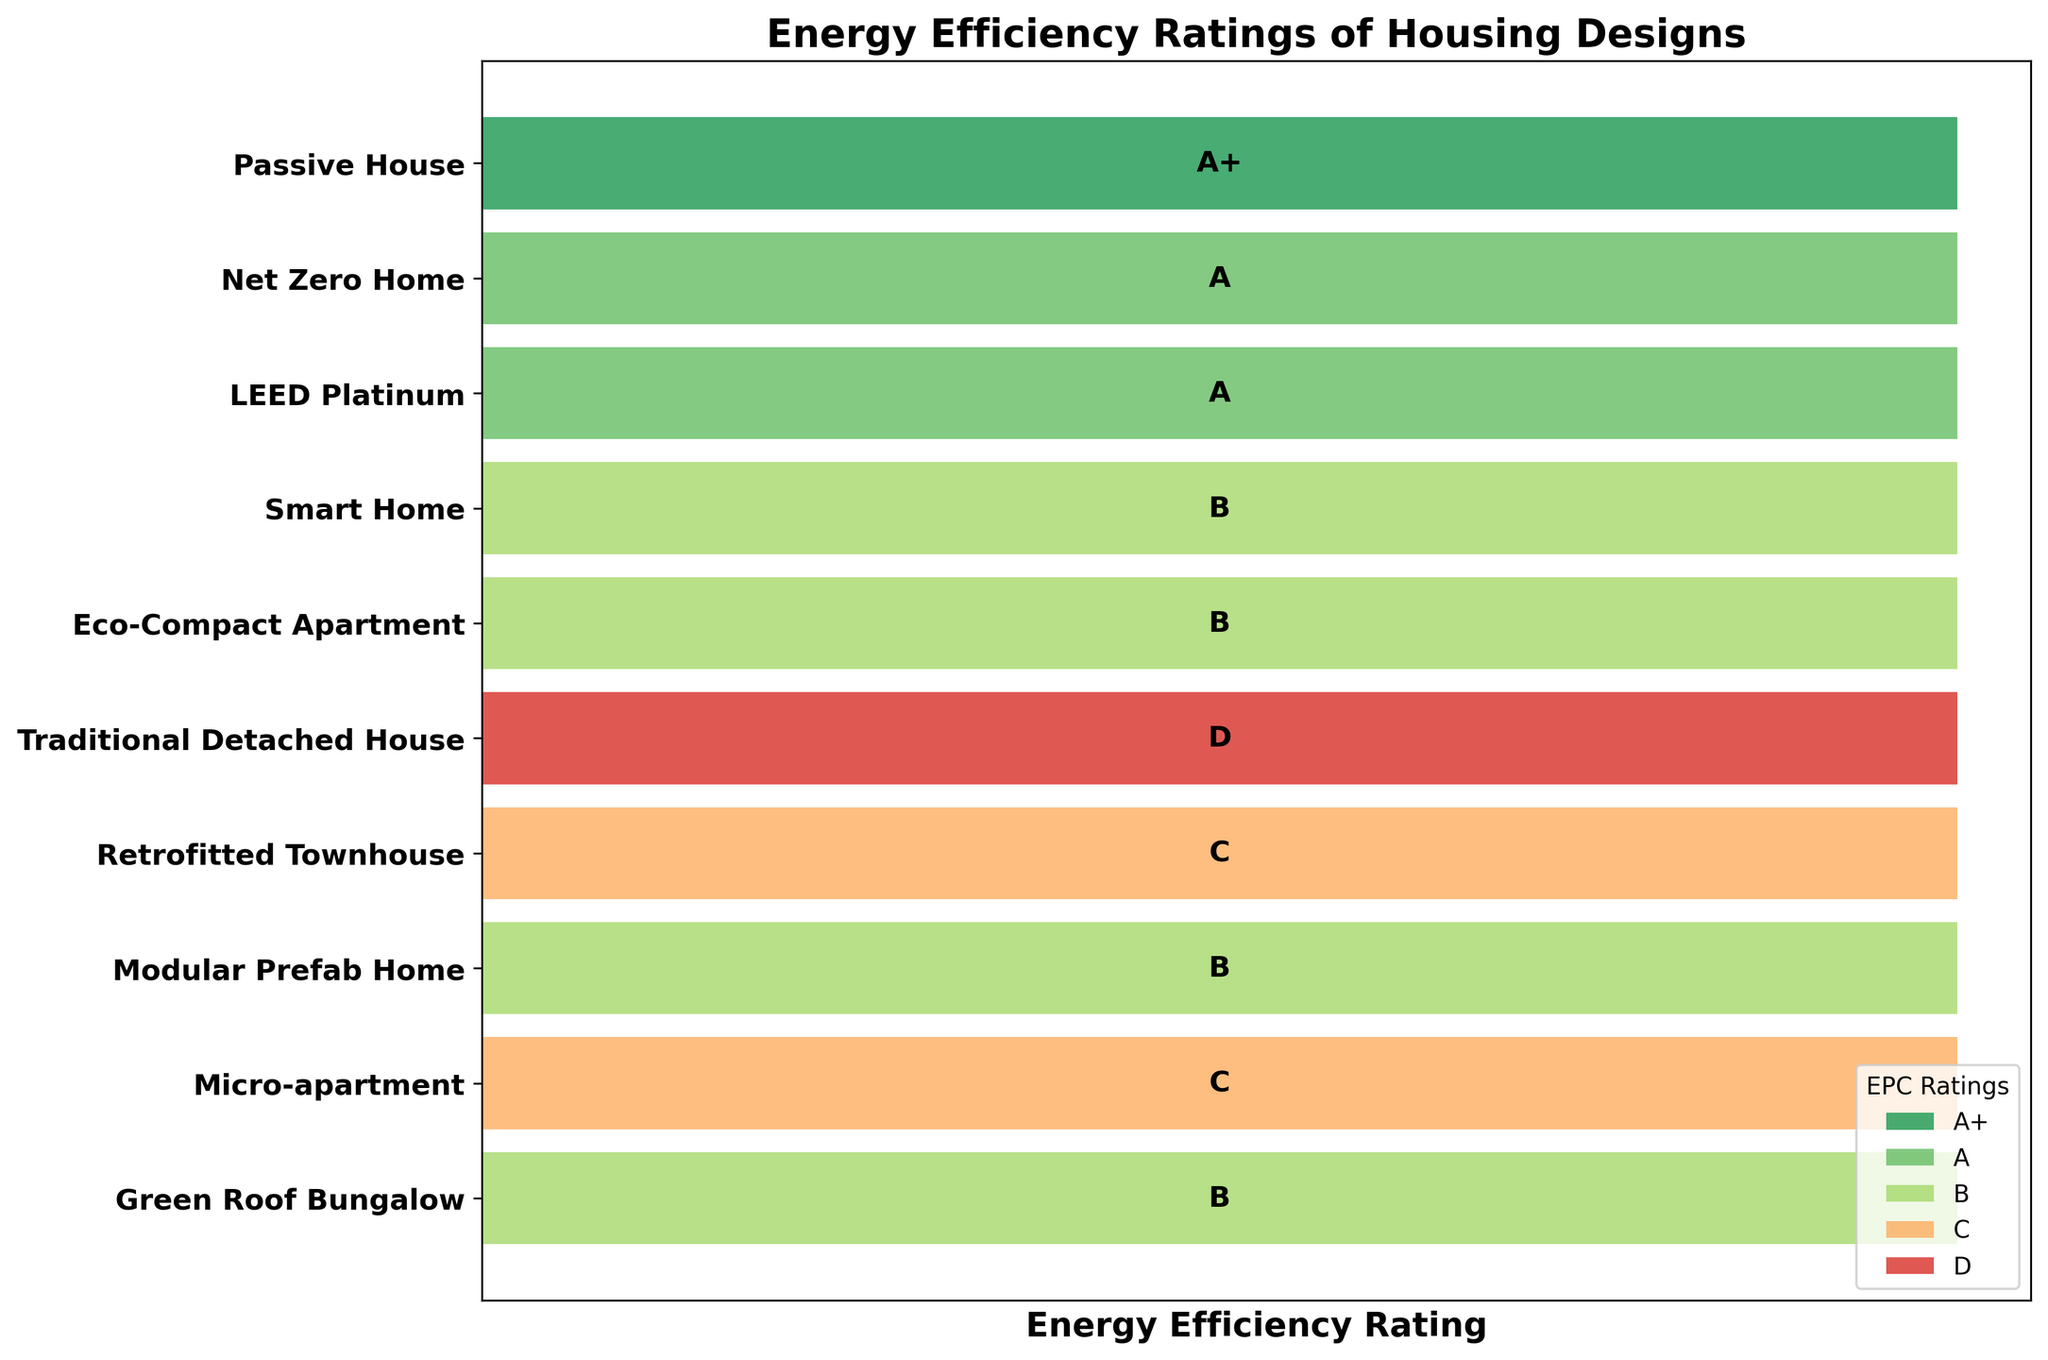How many unique housing designs are displayed in the figure? Count the number of different labels on the y-axis representing the designs.
Answer: 10 What is the title of the figure? The title is usually placed at the top of the graph.
Answer: Energy Efficiency Ratings of Housing Designs Which housing design has the highest energy efficiency rating? Identify the design label next to the bar with the highest rating of 'A+'.
Answer: Passive House How many housing designs have an energy efficiency rating of B? Count the bars shaded with the same color corresponding to the rating 'B'.
Answer: 5 What is the average energy efficiency rating for the displayed housing designs? Identify the ratings for all designs, assign numerical values (A+ = 1, A = 2, B = 3, C = 4, D = 5), sum them up, and divide by the number of designs.
Answer: 2.9 Which housing designs have a rating lower than a B? Identify the labels next to the bars rated as 'C' or 'D'.
Answer: Retrofitted Townhouse, Micro-apartment, Traditional Detached House What's the color code for the highest energy efficiency rating in the chart? Look at the legend and identify the color matching 'A+'.
Answer: Green Compare the number of houses with a rating of B to the number with a rating of C. Count the bars shaded with the colors for B and C, then compare the two counts.
Answer: 5 (B) vs. 2 (C) Which ratings appear more frequently, B or A? Count the number of bars marked with 'B' and 'A' and determine which is higher.
Answer: B What is the fourth housing design listed from the top and its energy efficiency rating? Read the label of the fourth bar from the top along with its marked rating.
Answer: Smart Home, B 